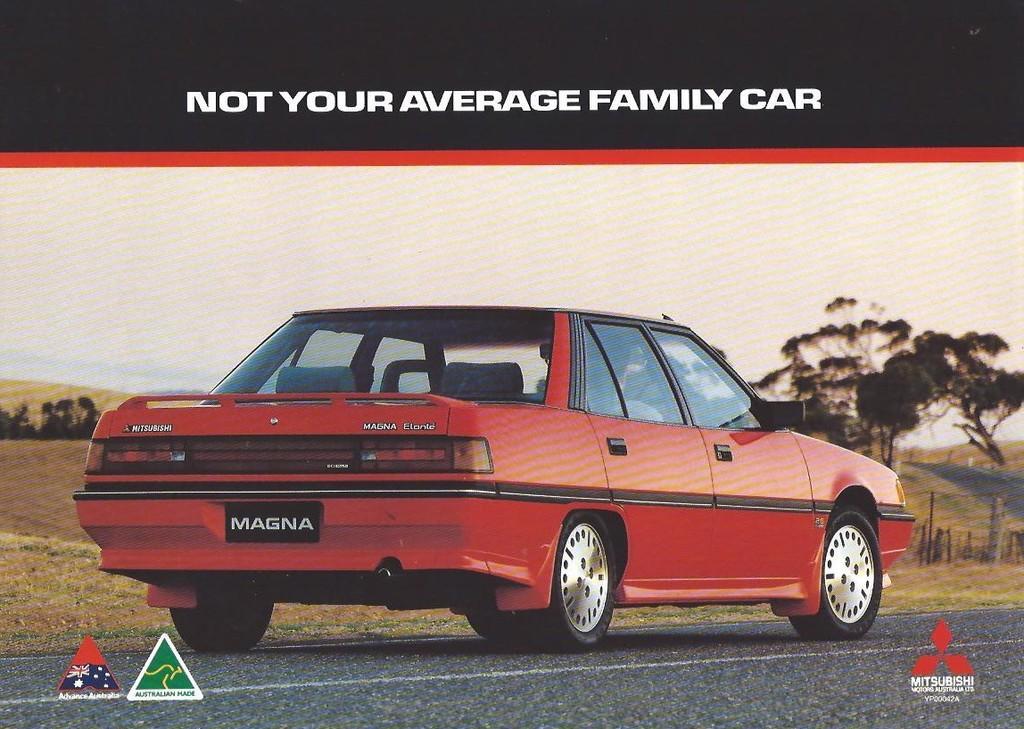In one or two sentences, can you explain what this image depicts? In this image there is a poster, there is text towards the top of the image, there is text towards the bottom of the image, there is the sky, there are trees, there is the road towards the bottom of the image, there is a car on the road. 